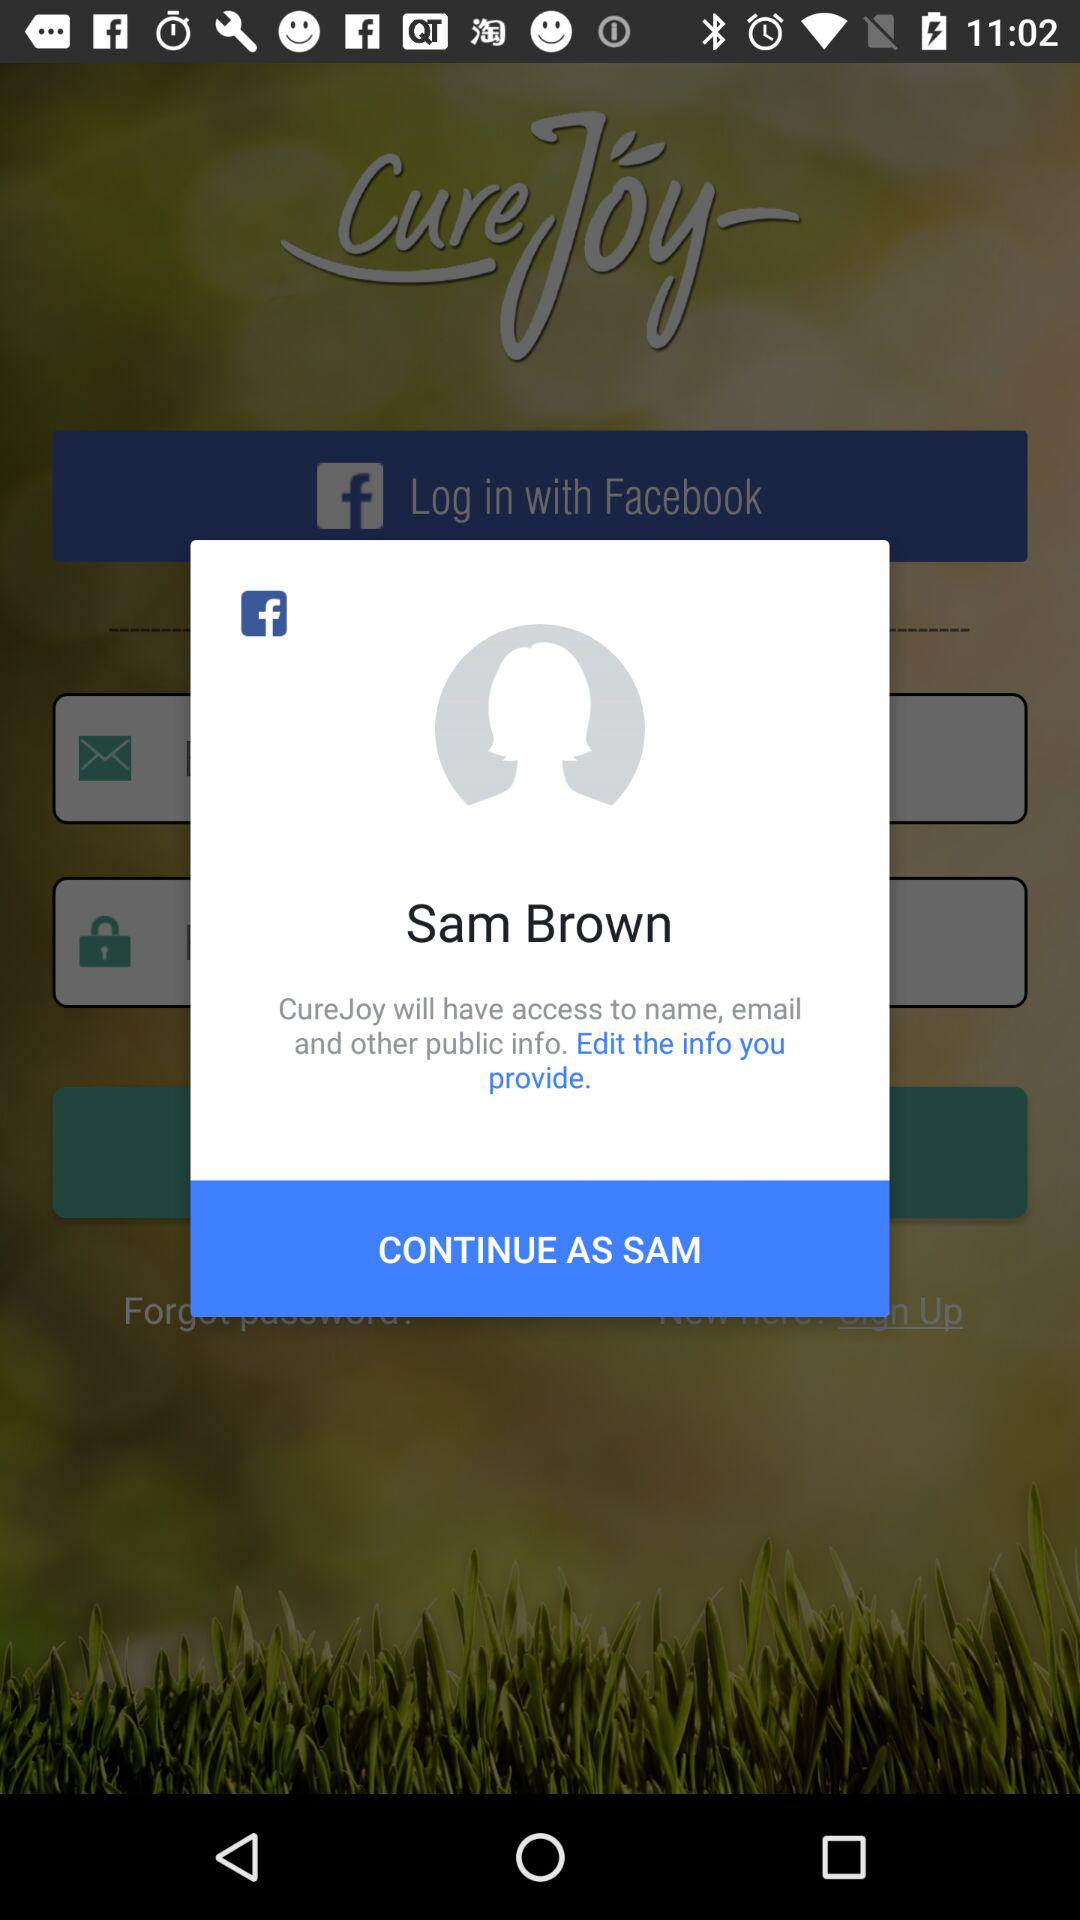What application can we use to log in? You can use "Facebook" application to log in. 